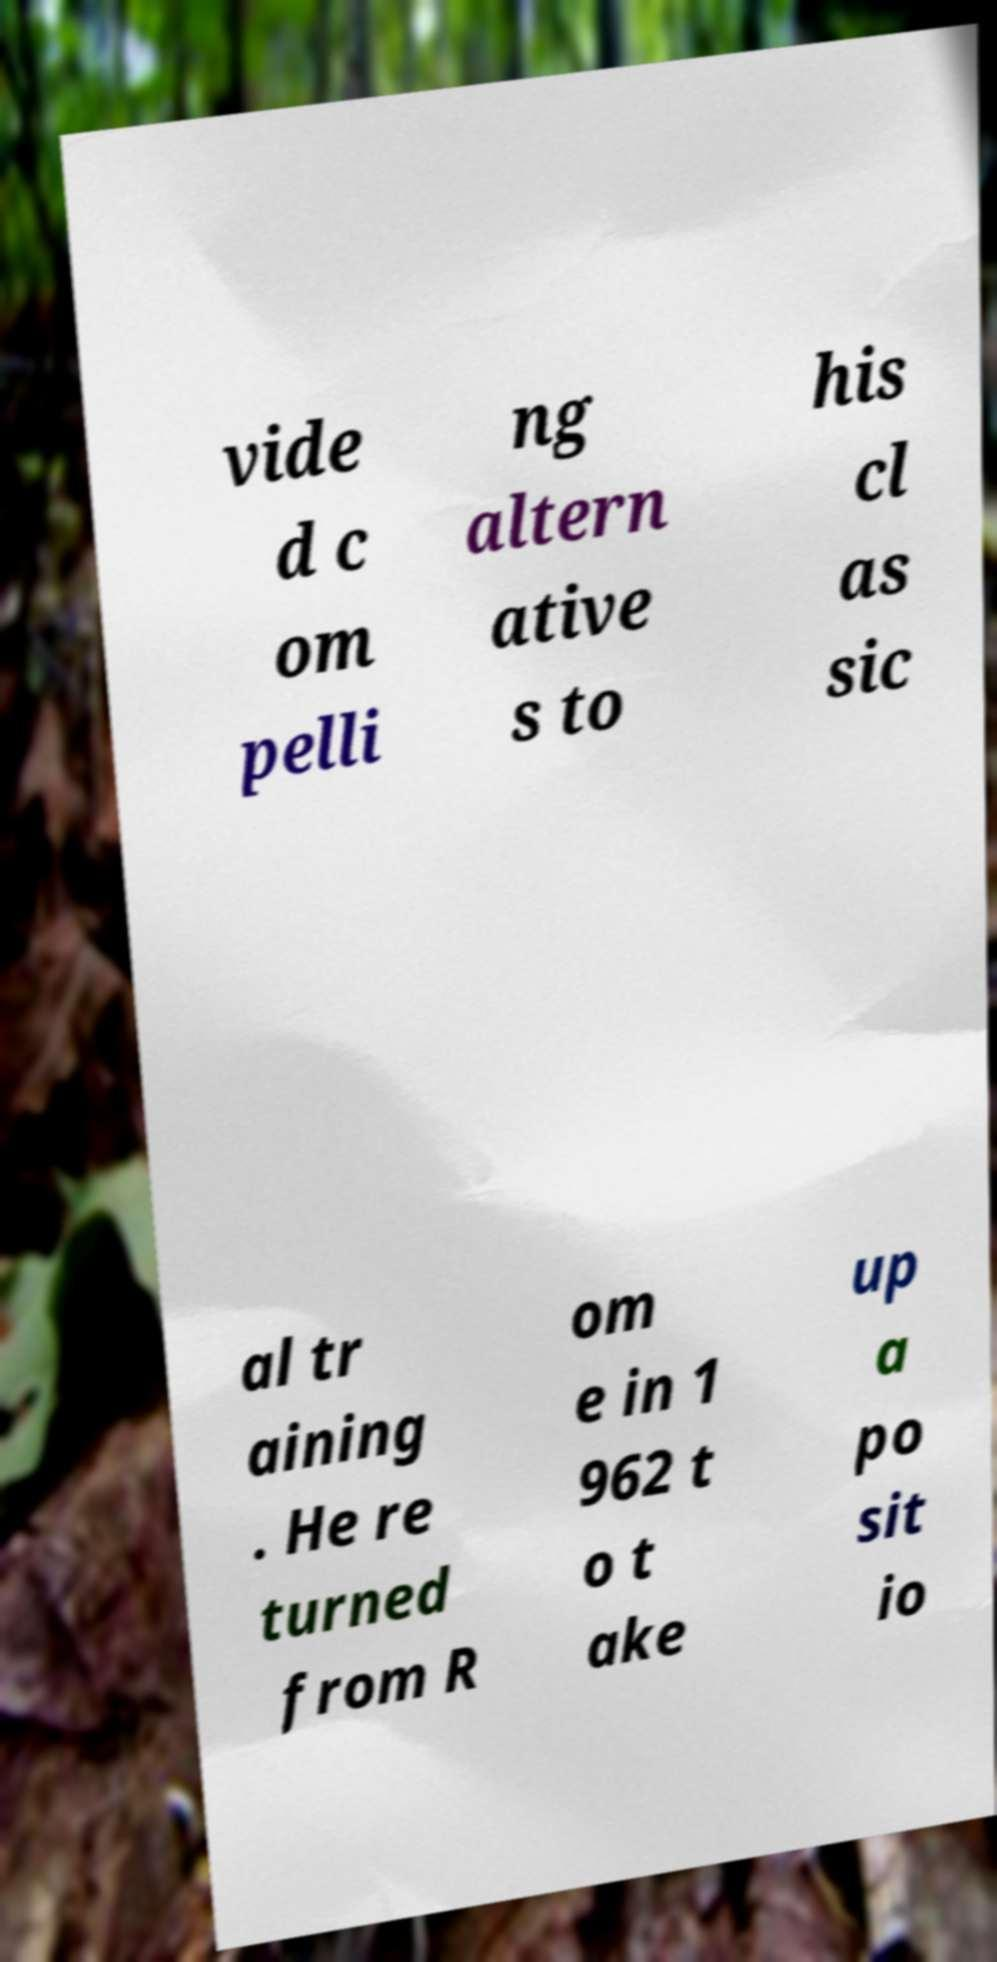Please read and relay the text visible in this image. What does it say? vide d c om pelli ng altern ative s to his cl as sic al tr aining . He re turned from R om e in 1 962 t o t ake up a po sit io 